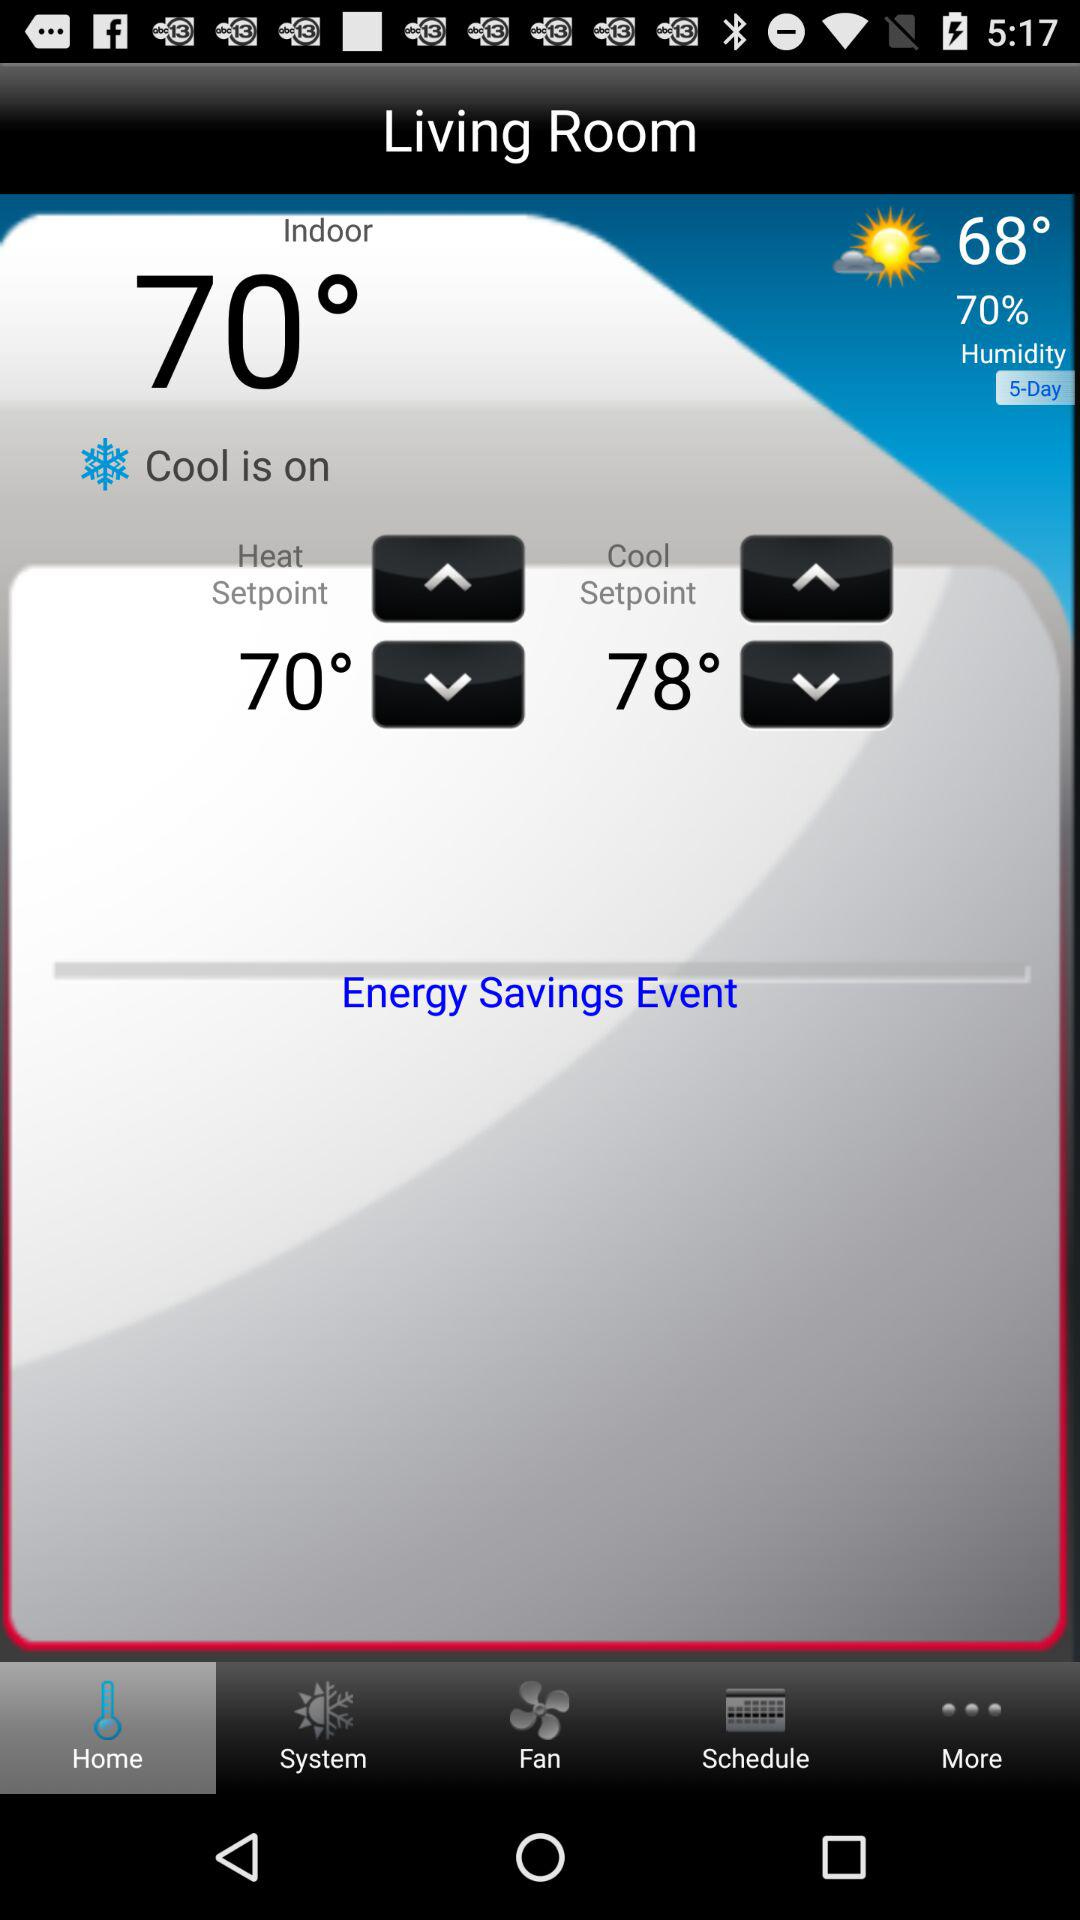What is the "Cool Setpoint"? The "Cool Setpoint" is 78°. 